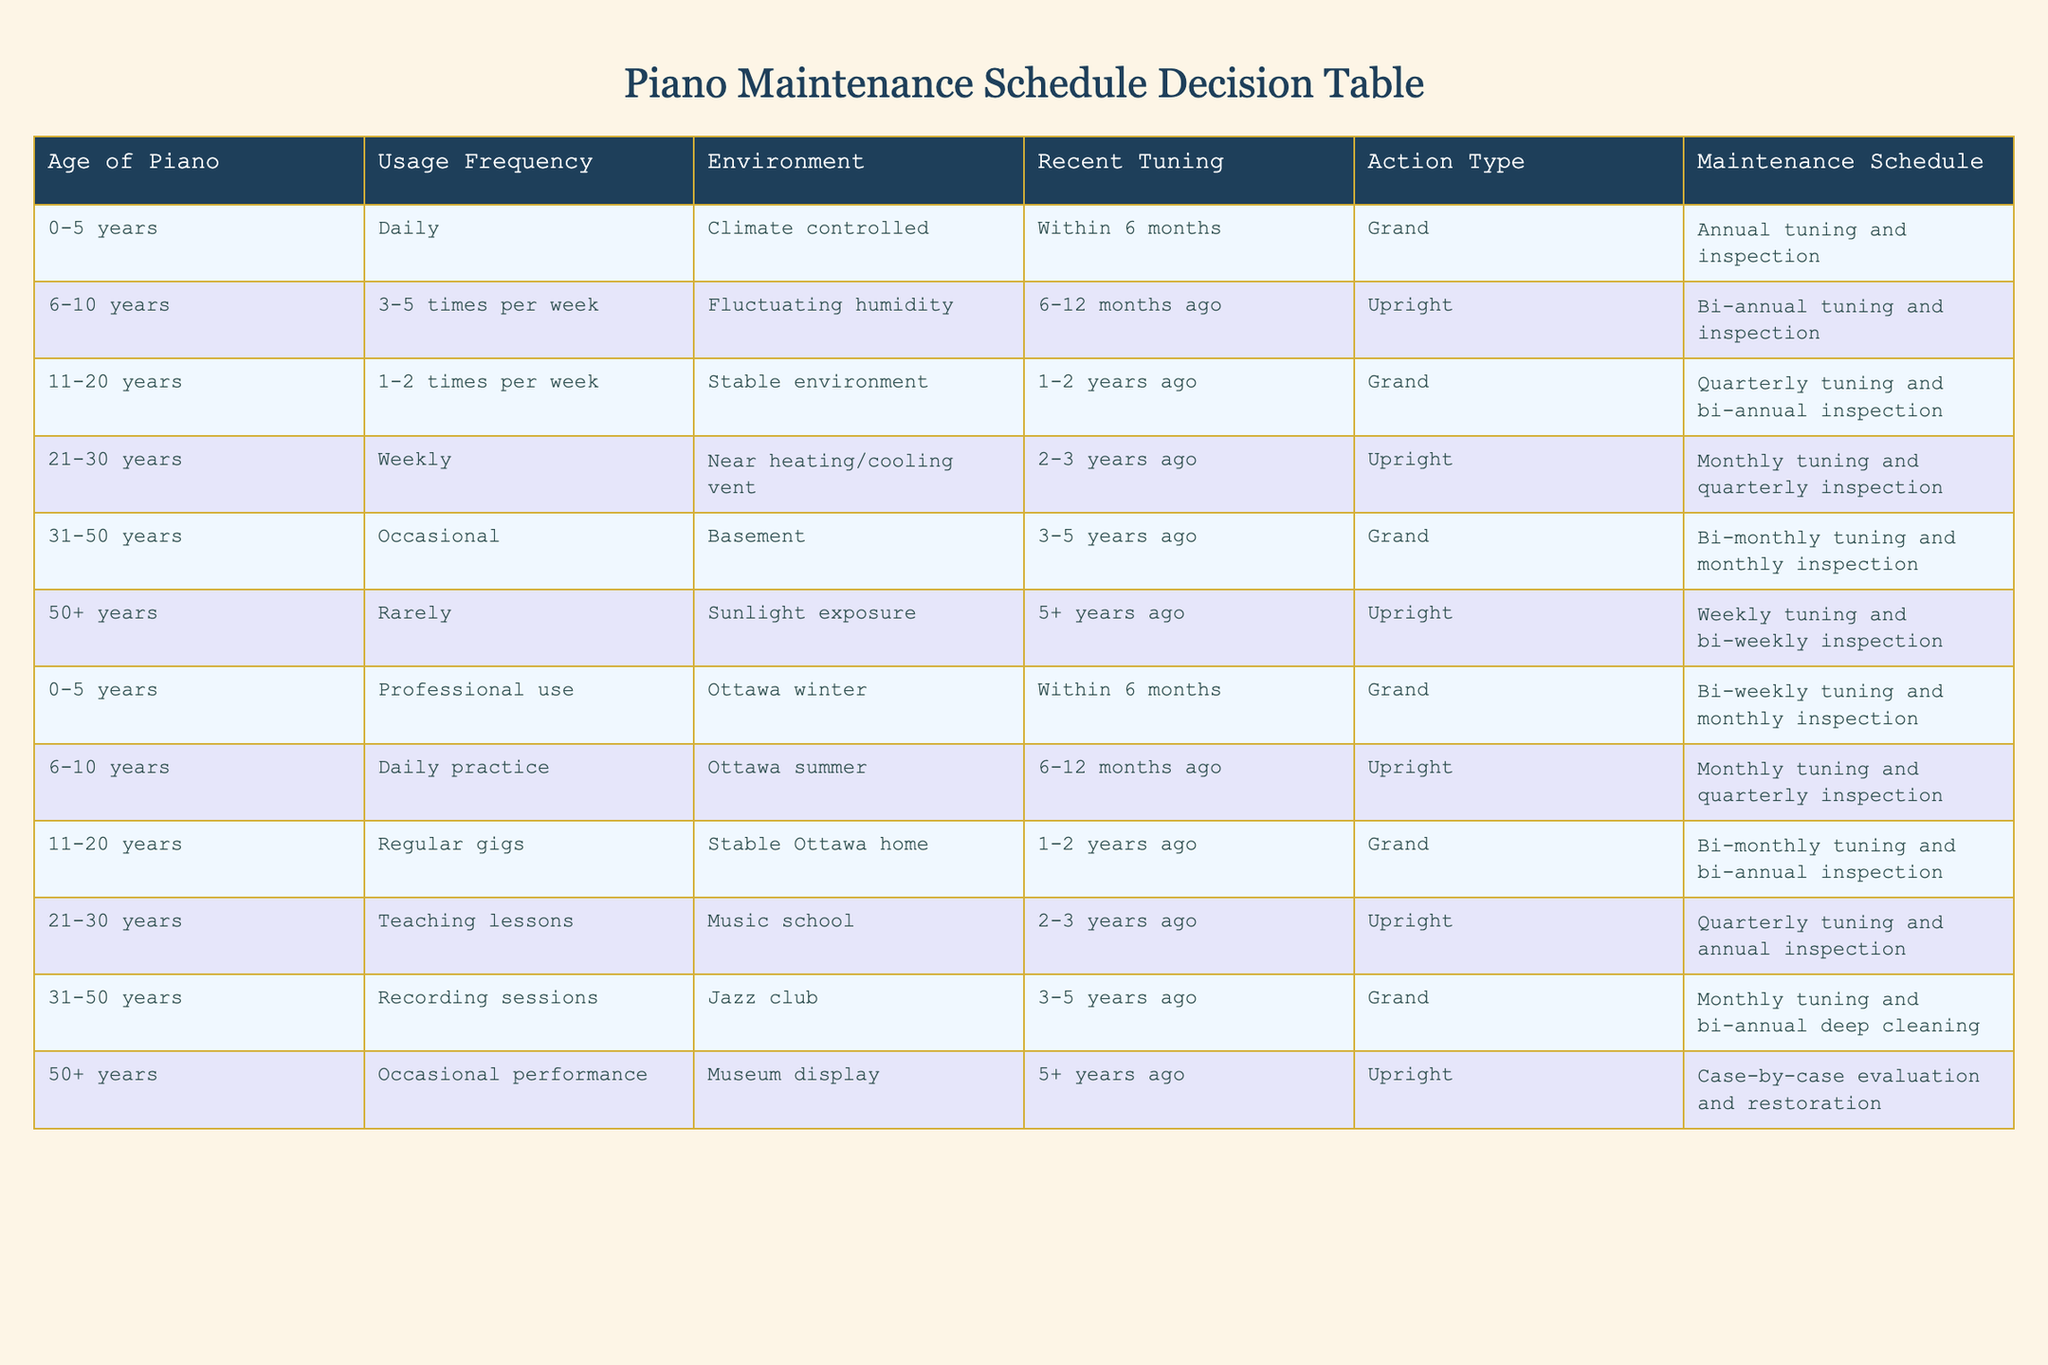What is the maintenance schedule for a piano aged 6-10 years used for daily practice? The table indicates that a piano aged 6-10 years used for daily practice and in the Ottawa summer environment has a maintenance schedule of monthly tuning and quarterly inspection.
Answer: Monthly tuning and quarterly inspection How often should a 21-30 year old uprights piano in a music school be tuned? According to the table, a 21-30 year old upright piano in a music school receives quarterly tuning and annual inspection.
Answer: Quarterly tuning Is a piano aged 50+ years that is used rarely in sunlight exposure scheduled for weekly tuning? The table shows that a 50+ year old piano that is used rarely and exposed to sunlight has a maintenance schedule that includes weekly tuning and bi-weekly inspection. Therefore, the statement is true.
Answer: Yes What is the frequency of inspection for a grand piano aged 31-50 years used for occasional recording sessions? The maintenance for a grand piano aged 31-50 years used for occasional recording sessions includes monthly tuning and bi-annual deep cleaning, indicating that while there is no specific inspection mentioned, deep cleaning is performed twice a year.
Answer: Bi-annual deep cleaning Can a 0-5 year old piano used for professional events in Ottawa winter be inspected less frequently than bi-monthly? Looking at the table, the maintenance schedule for a 0-5 year old grand piano used for professional work includes bi-weekly tuning and monthly inspection. Therefore, it cannot be inspected less frequently than bi-monthly, as the scheduling requires.
Answer: No What is the average age of pianos that require monthly tuning? To find the average age, we look at the rows where the maintenance schedule includes monthly tuning. These ages are 21-30 (1 piano), 31-50 (1 piano), and 0-5 years (1 piano for professional use). The ages can be approximated as (25 + 45 + 3)/3 = 24.33 (considering the midpoint of age ranges). The average age of the pianos requiring monthly tuning is therefore approximately 24 years.
Answer: Approximately 24 years What type of piano maintenance is scheduled for a 11-20 year old grand piano that was tuned 1-2 years ago? The table specifies that a grand piano aged 11-20 years that was last tuned 1-2 years ago is scheduled for bi-monthly tuning and bi-annual inspection.
Answer: Bi-monthly tuning and bi-annual inspection What action type is indicated for a piano older than 50 years if it has not been tuned for over 5 years? The table states that a piano older than 50 years that hasn't been tuned in over 5 years is subject to case-by-case evaluation and restoration.
Answer: Case-by-case evaluation and restoration 